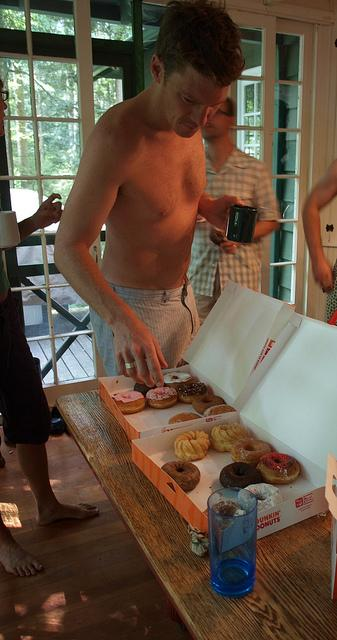What is the donut called that has ridges down the sides? cruller 